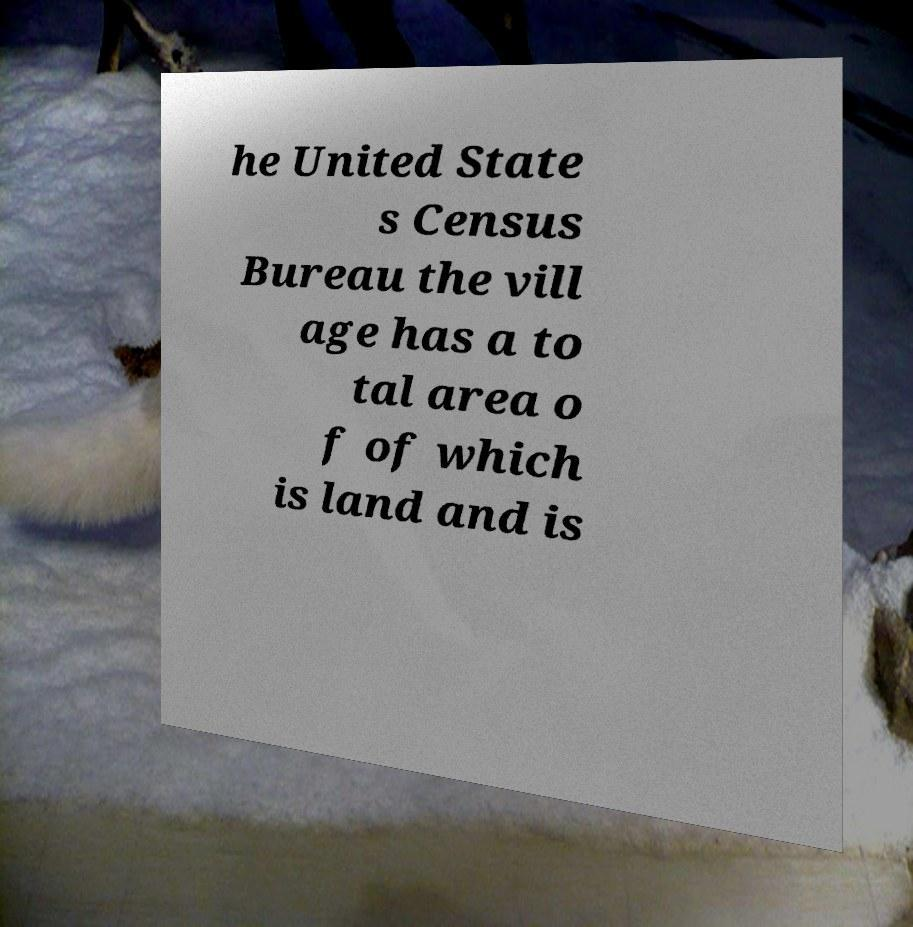Please read and relay the text visible in this image. What does it say? he United State s Census Bureau the vill age has a to tal area o f of which is land and is 